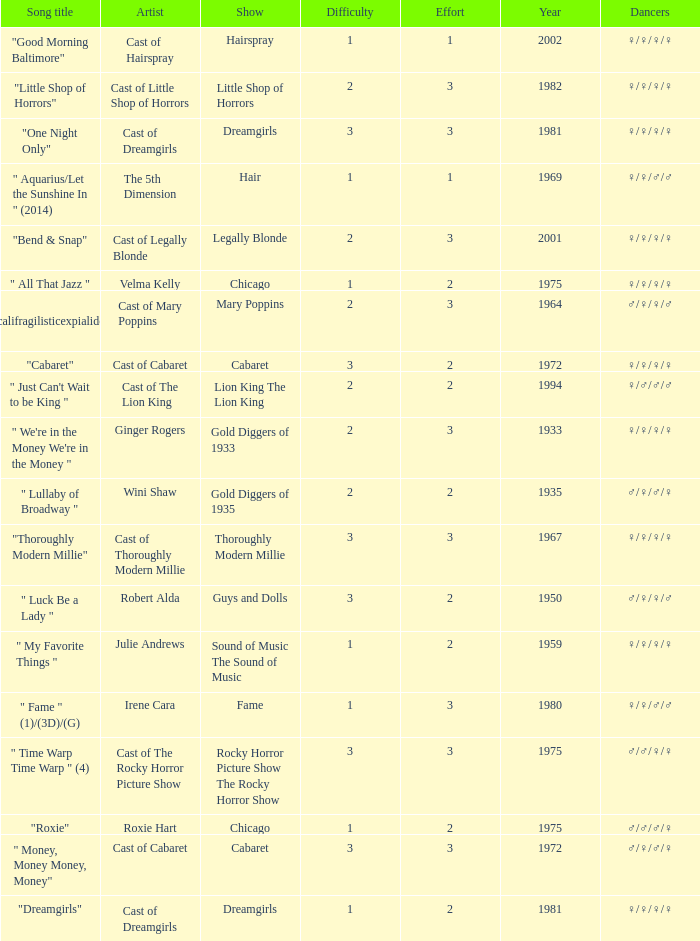How many artists were there for the show thoroughly modern millie? 1.0. 